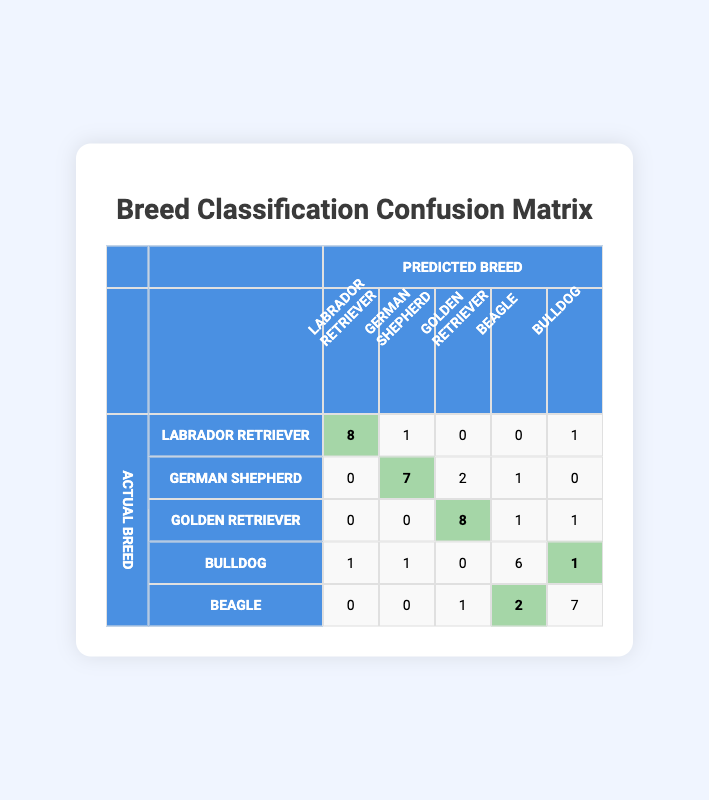What is the number of true positives for Golden Retriever? The true positives for Golden Retriever can be identified from the diagonal of the confusion matrix. The value in the row for Golden Retriever and the column for Golden Retriever is 8.
Answer: 8 How many instances of Bulldogs were misclassified as Beagles? To find this, look at the row for Bulldogs and the column for Beagle. The value is 2, indicating that 2 Bulldogs were misclassified as Beagles.
Answer: 2 What is the total number of actual instances for the Labrador Retriever breed? To calculate the total actual instances for Labrador Retrievers, we sum the corresponding row in the confusion matrix: 8 + 1 + 0 + 0 + 1 = 10.
Answer: 10 Is the model more accurate for the Golden Retriever compared to the Bulldog? To determine accuracy for each breed, we need to examine true positives versus misclassifications. For Golden Retriever, true positives are 8, and misclassifications are 1. For Bulldog, true positives are 6, and misclassifications are 2. Thus, accuracy is higher for Golden Retriever.
Answer: Yes What is the overall prediction accuracy of the model? The overall prediction accuracy is computed by taking the sum of true positives across all breeds and dividing by the total number of instances. The total true positives are (8 + 7 + 8 + 6 + 7 = 36), and the total instances can be found by summing all values in the confusion matrix (10 + 10 + 10 + 10 + 10 = 50). Thus, accuracy = 36/50 = 0.72 or 72%.
Answer: 72% How many Beagles were correctly identified? We can find the number of correctly identified Beagles by looking at the diagonal value for Beagle in the confusion matrix, which is 7.
Answer: 7 What is the total number of mislabeled instances across all breeds? To find the total mislabeled instances, we sum all values outside the diagonal of the confusion matrix. Counting these values yields: 1 (Labrador) + 0 + 1 + 1 (Bulldog) + 0 (Beagle) + 2 (German Shepherd) + 1 (German Shepherd) + 1 (Golden Retriever) + 1 (Golden Retriever) + 2 = 10.
Answer: 10 Which breed had the highest number of correct predictions? The breed with the highest number of correct predictions is Golden Retriever, with 8 true positives compared to others: Labrador Retriever (8), German Shepherd (7), Bulldog (6), and Beagle (7). However, Labrador also has 8.
Answer: Labrador Retriever and Golden Retriever What is the predicted label for the highest count of German Shepherd instances? In the confusion matrix, the predicted instances for German Shepherd can be identified in the row for German Shepherd. The predicted counts are: 0, 7, 2, 1, 0. The highest count is 7, matching the actual breed correctly classified.
Answer: German Shepherd 